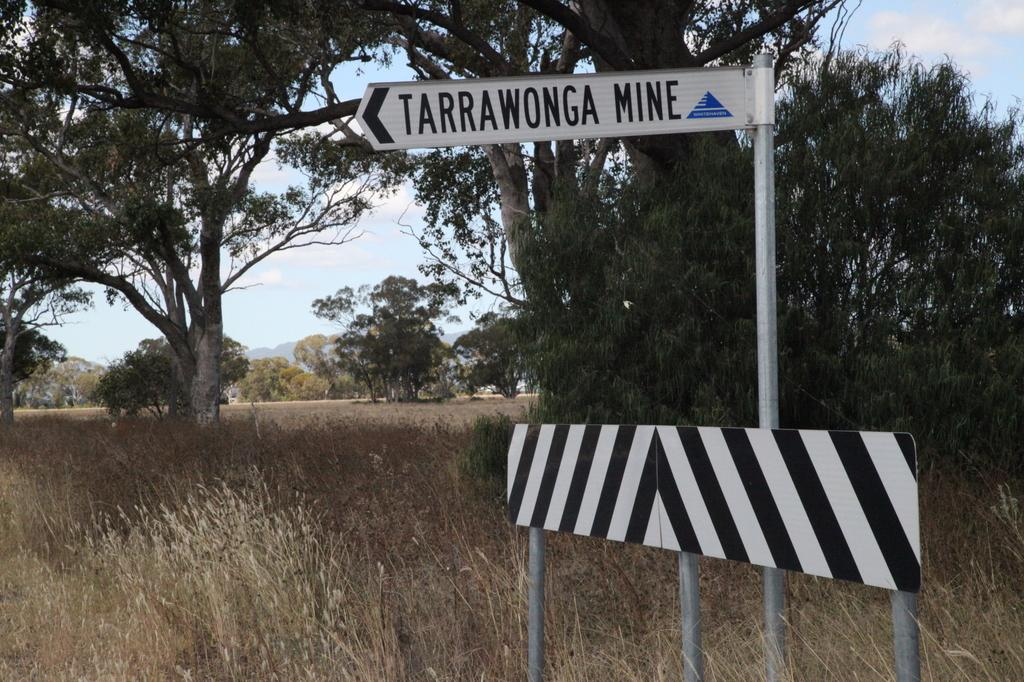What type of vegetation is present in the image? There is grass and trees in the image. What can be seen in the sky in the image? There are clouds in the image, and the sky is visible. What structures are present in the image? There are poles and boards in the image. Is there any text or writing in the image? Yes, there is writing on at least one of the boards. How many sticks of butter are visible in the image? There is no butter present in the image. What type of insects can be seen crawling on the grass in the image? There are no insects, including ants, visible in the image. 